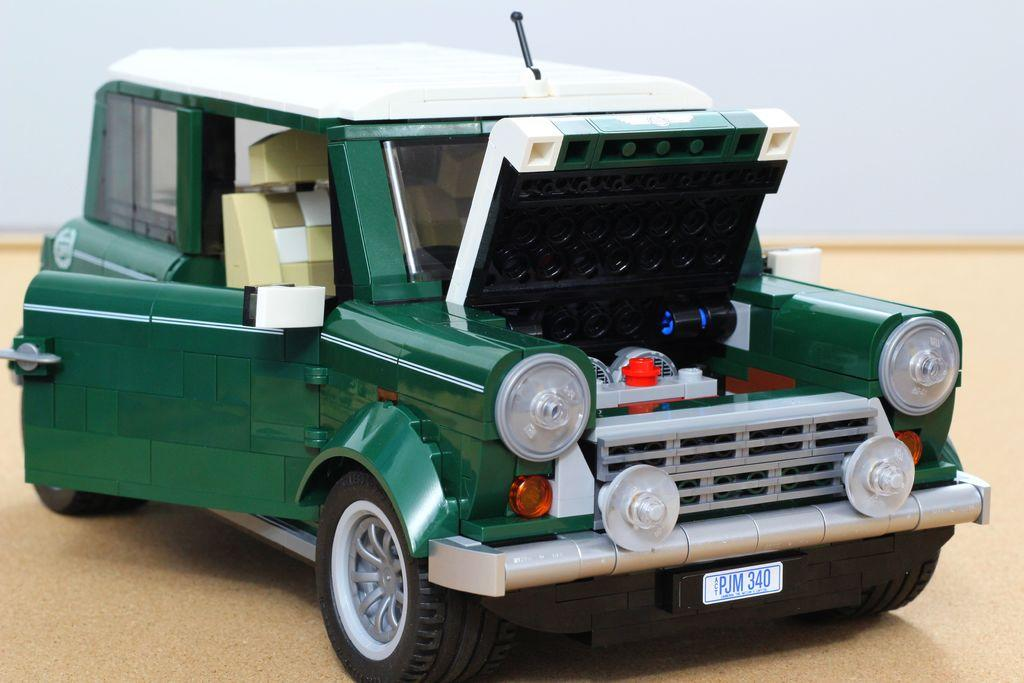What is the main object in the image? There is a toy car in the image. What is the toy car placed on? The toy car is on a wooden surface. What can be seen in the background of the image? There is a wall visible in the image. What type of decision is the toy car making in the image? The toy car is not capable of making decisions, as it is an inanimate object. 